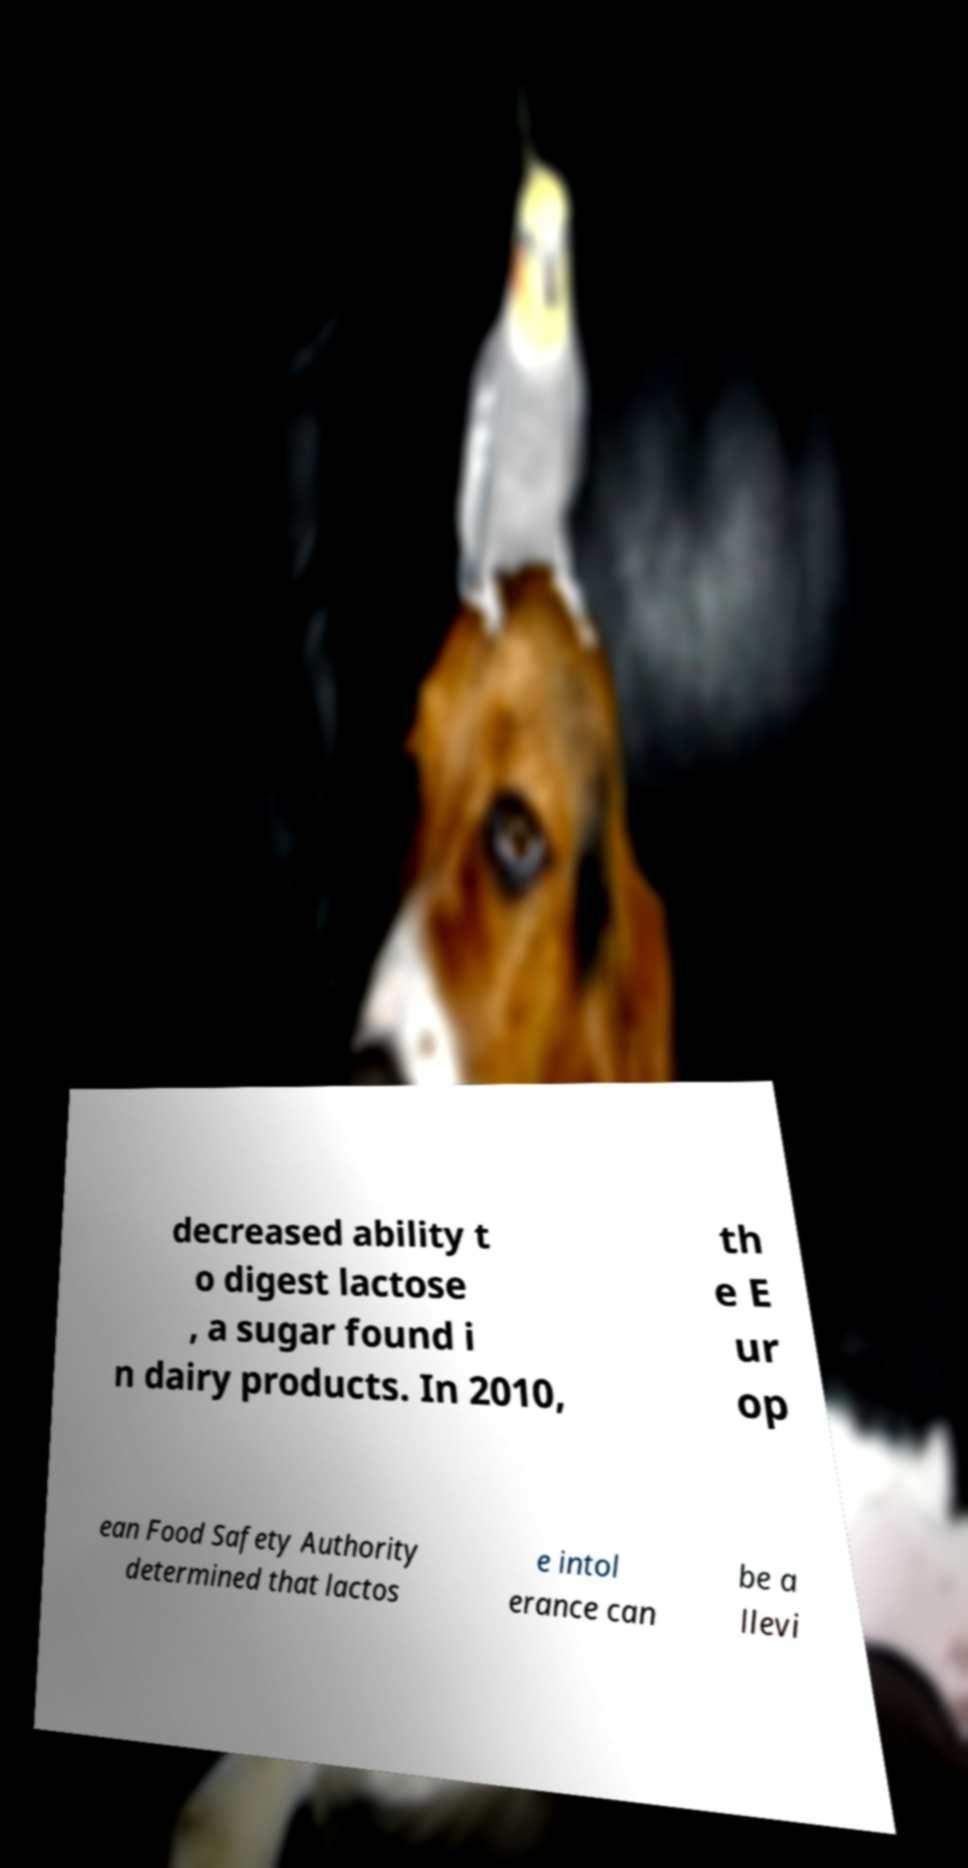Please read and relay the text visible in this image. What does it say? decreased ability t o digest lactose , a sugar found i n dairy products. In 2010, th e E ur op ean Food Safety Authority determined that lactos e intol erance can be a llevi 